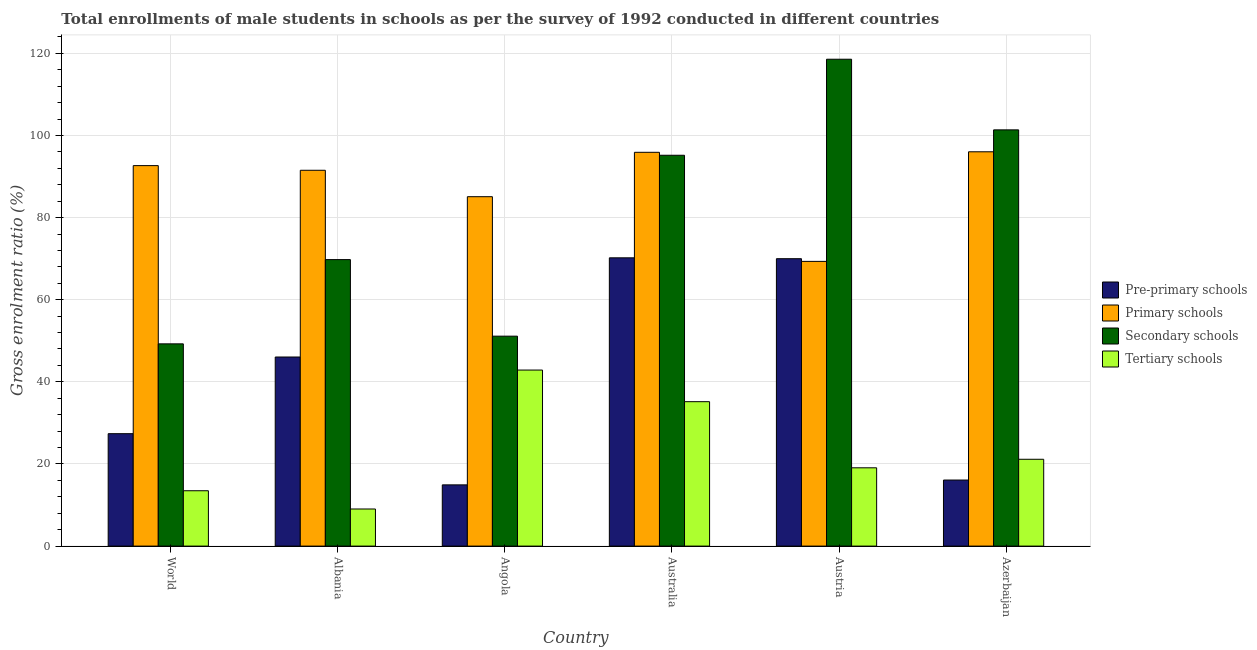How many different coloured bars are there?
Give a very brief answer. 4. How many groups of bars are there?
Ensure brevity in your answer.  6. Are the number of bars per tick equal to the number of legend labels?
Provide a succinct answer. Yes. Are the number of bars on each tick of the X-axis equal?
Your response must be concise. Yes. How many bars are there on the 1st tick from the left?
Make the answer very short. 4. What is the label of the 6th group of bars from the left?
Your answer should be very brief. Azerbaijan. What is the gross enrolment ratio(male) in secondary schools in Angola?
Make the answer very short. 51.12. Across all countries, what is the maximum gross enrolment ratio(male) in secondary schools?
Your answer should be compact. 118.57. Across all countries, what is the minimum gross enrolment ratio(male) in secondary schools?
Make the answer very short. 49.25. In which country was the gross enrolment ratio(male) in pre-primary schools minimum?
Ensure brevity in your answer.  Angola. What is the total gross enrolment ratio(male) in pre-primary schools in the graph?
Offer a very short reply. 244.62. What is the difference between the gross enrolment ratio(male) in secondary schools in Albania and that in Australia?
Your response must be concise. -25.41. What is the difference between the gross enrolment ratio(male) in pre-primary schools in Australia and the gross enrolment ratio(male) in primary schools in Azerbaijan?
Make the answer very short. -25.82. What is the average gross enrolment ratio(male) in primary schools per country?
Your response must be concise. 88.42. What is the difference between the gross enrolment ratio(male) in pre-primary schools and gross enrolment ratio(male) in tertiary schools in Austria?
Provide a succinct answer. 50.92. In how many countries, is the gross enrolment ratio(male) in secondary schools greater than 88 %?
Your answer should be compact. 3. What is the ratio of the gross enrolment ratio(male) in pre-primary schools in Angola to that in Azerbaijan?
Offer a terse response. 0.93. Is the gross enrolment ratio(male) in tertiary schools in Angola less than that in World?
Your answer should be compact. No. Is the difference between the gross enrolment ratio(male) in pre-primary schools in Australia and Azerbaijan greater than the difference between the gross enrolment ratio(male) in secondary schools in Australia and Azerbaijan?
Give a very brief answer. Yes. What is the difference between the highest and the second highest gross enrolment ratio(male) in tertiary schools?
Give a very brief answer. 7.7. What is the difference between the highest and the lowest gross enrolment ratio(male) in tertiary schools?
Offer a terse response. 33.84. In how many countries, is the gross enrolment ratio(male) in pre-primary schools greater than the average gross enrolment ratio(male) in pre-primary schools taken over all countries?
Give a very brief answer. 3. Is it the case that in every country, the sum of the gross enrolment ratio(male) in tertiary schools and gross enrolment ratio(male) in secondary schools is greater than the sum of gross enrolment ratio(male) in pre-primary schools and gross enrolment ratio(male) in primary schools?
Your response must be concise. No. What does the 3rd bar from the left in Azerbaijan represents?
Your response must be concise. Secondary schools. What does the 1st bar from the right in Azerbaijan represents?
Keep it short and to the point. Tertiary schools. What is the difference between two consecutive major ticks on the Y-axis?
Ensure brevity in your answer.  20. Are the values on the major ticks of Y-axis written in scientific E-notation?
Your answer should be very brief. No. Does the graph contain grids?
Ensure brevity in your answer.  Yes. Where does the legend appear in the graph?
Give a very brief answer. Center right. How are the legend labels stacked?
Ensure brevity in your answer.  Vertical. What is the title of the graph?
Your response must be concise. Total enrollments of male students in schools as per the survey of 1992 conducted in different countries. What is the label or title of the Y-axis?
Offer a very short reply. Gross enrolment ratio (%). What is the Gross enrolment ratio (%) in Pre-primary schools in World?
Offer a very short reply. 27.38. What is the Gross enrolment ratio (%) in Primary schools in World?
Make the answer very short. 92.66. What is the Gross enrolment ratio (%) of Secondary schools in World?
Offer a terse response. 49.25. What is the Gross enrolment ratio (%) in Tertiary schools in World?
Provide a short and direct response. 13.48. What is the Gross enrolment ratio (%) in Pre-primary schools in Albania?
Offer a terse response. 46.05. What is the Gross enrolment ratio (%) of Primary schools in Albania?
Ensure brevity in your answer.  91.53. What is the Gross enrolment ratio (%) of Secondary schools in Albania?
Give a very brief answer. 69.77. What is the Gross enrolment ratio (%) of Tertiary schools in Albania?
Provide a succinct answer. 9.04. What is the Gross enrolment ratio (%) of Pre-primary schools in Angola?
Offer a terse response. 14.91. What is the Gross enrolment ratio (%) in Primary schools in Angola?
Ensure brevity in your answer.  85.09. What is the Gross enrolment ratio (%) of Secondary schools in Angola?
Keep it short and to the point. 51.12. What is the Gross enrolment ratio (%) in Tertiary schools in Angola?
Offer a terse response. 42.87. What is the Gross enrolment ratio (%) of Pre-primary schools in Australia?
Provide a succinct answer. 70.2. What is the Gross enrolment ratio (%) in Primary schools in Australia?
Give a very brief answer. 95.9. What is the Gross enrolment ratio (%) of Secondary schools in Australia?
Offer a very short reply. 95.18. What is the Gross enrolment ratio (%) in Tertiary schools in Australia?
Your response must be concise. 35.17. What is the Gross enrolment ratio (%) of Pre-primary schools in Austria?
Provide a succinct answer. 69.99. What is the Gross enrolment ratio (%) in Primary schools in Austria?
Provide a succinct answer. 69.34. What is the Gross enrolment ratio (%) in Secondary schools in Austria?
Provide a short and direct response. 118.57. What is the Gross enrolment ratio (%) of Tertiary schools in Austria?
Your answer should be very brief. 19.07. What is the Gross enrolment ratio (%) in Pre-primary schools in Azerbaijan?
Provide a succinct answer. 16.09. What is the Gross enrolment ratio (%) of Primary schools in Azerbaijan?
Provide a short and direct response. 96.03. What is the Gross enrolment ratio (%) in Secondary schools in Azerbaijan?
Your answer should be compact. 101.37. What is the Gross enrolment ratio (%) of Tertiary schools in Azerbaijan?
Keep it short and to the point. 21.14. Across all countries, what is the maximum Gross enrolment ratio (%) of Pre-primary schools?
Offer a very short reply. 70.2. Across all countries, what is the maximum Gross enrolment ratio (%) of Primary schools?
Give a very brief answer. 96.03. Across all countries, what is the maximum Gross enrolment ratio (%) in Secondary schools?
Keep it short and to the point. 118.57. Across all countries, what is the maximum Gross enrolment ratio (%) in Tertiary schools?
Your answer should be compact. 42.87. Across all countries, what is the minimum Gross enrolment ratio (%) in Pre-primary schools?
Make the answer very short. 14.91. Across all countries, what is the minimum Gross enrolment ratio (%) in Primary schools?
Offer a very short reply. 69.34. Across all countries, what is the minimum Gross enrolment ratio (%) of Secondary schools?
Your answer should be compact. 49.25. Across all countries, what is the minimum Gross enrolment ratio (%) of Tertiary schools?
Your answer should be very brief. 9.04. What is the total Gross enrolment ratio (%) of Pre-primary schools in the graph?
Your answer should be compact. 244.62. What is the total Gross enrolment ratio (%) in Primary schools in the graph?
Make the answer very short. 530.55. What is the total Gross enrolment ratio (%) of Secondary schools in the graph?
Offer a terse response. 485.27. What is the total Gross enrolment ratio (%) of Tertiary schools in the graph?
Keep it short and to the point. 140.77. What is the difference between the Gross enrolment ratio (%) in Pre-primary schools in World and that in Albania?
Your answer should be compact. -18.67. What is the difference between the Gross enrolment ratio (%) of Primary schools in World and that in Albania?
Provide a succinct answer. 1.13. What is the difference between the Gross enrolment ratio (%) of Secondary schools in World and that in Albania?
Provide a short and direct response. -20.52. What is the difference between the Gross enrolment ratio (%) of Tertiary schools in World and that in Albania?
Provide a succinct answer. 4.45. What is the difference between the Gross enrolment ratio (%) of Pre-primary schools in World and that in Angola?
Provide a succinct answer. 12.47. What is the difference between the Gross enrolment ratio (%) in Primary schools in World and that in Angola?
Provide a succinct answer. 7.57. What is the difference between the Gross enrolment ratio (%) of Secondary schools in World and that in Angola?
Your response must be concise. -1.87. What is the difference between the Gross enrolment ratio (%) of Tertiary schools in World and that in Angola?
Your answer should be very brief. -29.39. What is the difference between the Gross enrolment ratio (%) in Pre-primary schools in World and that in Australia?
Your response must be concise. -42.82. What is the difference between the Gross enrolment ratio (%) of Primary schools in World and that in Australia?
Offer a terse response. -3.24. What is the difference between the Gross enrolment ratio (%) of Secondary schools in World and that in Australia?
Offer a terse response. -45.93. What is the difference between the Gross enrolment ratio (%) of Tertiary schools in World and that in Australia?
Provide a succinct answer. -21.69. What is the difference between the Gross enrolment ratio (%) of Pre-primary schools in World and that in Austria?
Your response must be concise. -42.61. What is the difference between the Gross enrolment ratio (%) in Primary schools in World and that in Austria?
Provide a succinct answer. 23.32. What is the difference between the Gross enrolment ratio (%) in Secondary schools in World and that in Austria?
Your answer should be compact. -69.32. What is the difference between the Gross enrolment ratio (%) in Tertiary schools in World and that in Austria?
Provide a succinct answer. -5.58. What is the difference between the Gross enrolment ratio (%) of Pre-primary schools in World and that in Azerbaijan?
Ensure brevity in your answer.  11.29. What is the difference between the Gross enrolment ratio (%) in Primary schools in World and that in Azerbaijan?
Your response must be concise. -3.37. What is the difference between the Gross enrolment ratio (%) of Secondary schools in World and that in Azerbaijan?
Provide a short and direct response. -52.11. What is the difference between the Gross enrolment ratio (%) of Tertiary schools in World and that in Azerbaijan?
Your answer should be very brief. -7.66. What is the difference between the Gross enrolment ratio (%) in Pre-primary schools in Albania and that in Angola?
Provide a succinct answer. 31.14. What is the difference between the Gross enrolment ratio (%) of Primary schools in Albania and that in Angola?
Your answer should be compact. 6.44. What is the difference between the Gross enrolment ratio (%) in Secondary schools in Albania and that in Angola?
Ensure brevity in your answer.  18.65. What is the difference between the Gross enrolment ratio (%) in Tertiary schools in Albania and that in Angola?
Keep it short and to the point. -33.84. What is the difference between the Gross enrolment ratio (%) in Pre-primary schools in Albania and that in Australia?
Give a very brief answer. -24.15. What is the difference between the Gross enrolment ratio (%) of Primary schools in Albania and that in Australia?
Keep it short and to the point. -4.38. What is the difference between the Gross enrolment ratio (%) of Secondary schools in Albania and that in Australia?
Offer a very short reply. -25.41. What is the difference between the Gross enrolment ratio (%) in Tertiary schools in Albania and that in Australia?
Your answer should be compact. -26.14. What is the difference between the Gross enrolment ratio (%) in Pre-primary schools in Albania and that in Austria?
Provide a succinct answer. -23.94. What is the difference between the Gross enrolment ratio (%) of Primary schools in Albania and that in Austria?
Provide a succinct answer. 22.19. What is the difference between the Gross enrolment ratio (%) of Secondary schools in Albania and that in Austria?
Offer a very short reply. -48.8. What is the difference between the Gross enrolment ratio (%) of Tertiary schools in Albania and that in Austria?
Your answer should be very brief. -10.03. What is the difference between the Gross enrolment ratio (%) in Pre-primary schools in Albania and that in Azerbaijan?
Ensure brevity in your answer.  29.96. What is the difference between the Gross enrolment ratio (%) of Primary schools in Albania and that in Azerbaijan?
Provide a short and direct response. -4.5. What is the difference between the Gross enrolment ratio (%) of Secondary schools in Albania and that in Azerbaijan?
Keep it short and to the point. -31.6. What is the difference between the Gross enrolment ratio (%) in Tertiary schools in Albania and that in Azerbaijan?
Provide a short and direct response. -12.11. What is the difference between the Gross enrolment ratio (%) in Pre-primary schools in Angola and that in Australia?
Provide a succinct answer. -55.29. What is the difference between the Gross enrolment ratio (%) of Primary schools in Angola and that in Australia?
Provide a succinct answer. -10.81. What is the difference between the Gross enrolment ratio (%) of Secondary schools in Angola and that in Australia?
Make the answer very short. -44.06. What is the difference between the Gross enrolment ratio (%) in Tertiary schools in Angola and that in Australia?
Ensure brevity in your answer.  7.7. What is the difference between the Gross enrolment ratio (%) in Pre-primary schools in Angola and that in Austria?
Make the answer very short. -55.08. What is the difference between the Gross enrolment ratio (%) in Primary schools in Angola and that in Austria?
Make the answer very short. 15.75. What is the difference between the Gross enrolment ratio (%) of Secondary schools in Angola and that in Austria?
Your response must be concise. -67.45. What is the difference between the Gross enrolment ratio (%) in Tertiary schools in Angola and that in Austria?
Ensure brevity in your answer.  23.81. What is the difference between the Gross enrolment ratio (%) in Pre-primary schools in Angola and that in Azerbaijan?
Offer a very short reply. -1.18. What is the difference between the Gross enrolment ratio (%) of Primary schools in Angola and that in Azerbaijan?
Provide a short and direct response. -10.94. What is the difference between the Gross enrolment ratio (%) of Secondary schools in Angola and that in Azerbaijan?
Provide a succinct answer. -50.24. What is the difference between the Gross enrolment ratio (%) of Tertiary schools in Angola and that in Azerbaijan?
Your answer should be very brief. 21.73. What is the difference between the Gross enrolment ratio (%) in Pre-primary schools in Australia and that in Austria?
Offer a very short reply. 0.21. What is the difference between the Gross enrolment ratio (%) in Primary schools in Australia and that in Austria?
Your answer should be compact. 26.56. What is the difference between the Gross enrolment ratio (%) of Secondary schools in Australia and that in Austria?
Your answer should be very brief. -23.39. What is the difference between the Gross enrolment ratio (%) in Tertiary schools in Australia and that in Austria?
Make the answer very short. 16.11. What is the difference between the Gross enrolment ratio (%) of Pre-primary schools in Australia and that in Azerbaijan?
Ensure brevity in your answer.  54.12. What is the difference between the Gross enrolment ratio (%) in Primary schools in Australia and that in Azerbaijan?
Provide a succinct answer. -0.12. What is the difference between the Gross enrolment ratio (%) of Secondary schools in Australia and that in Azerbaijan?
Provide a succinct answer. -6.18. What is the difference between the Gross enrolment ratio (%) in Tertiary schools in Australia and that in Azerbaijan?
Make the answer very short. 14.03. What is the difference between the Gross enrolment ratio (%) in Pre-primary schools in Austria and that in Azerbaijan?
Provide a succinct answer. 53.9. What is the difference between the Gross enrolment ratio (%) in Primary schools in Austria and that in Azerbaijan?
Provide a short and direct response. -26.69. What is the difference between the Gross enrolment ratio (%) in Secondary schools in Austria and that in Azerbaijan?
Your answer should be very brief. 17.2. What is the difference between the Gross enrolment ratio (%) in Tertiary schools in Austria and that in Azerbaijan?
Your response must be concise. -2.08. What is the difference between the Gross enrolment ratio (%) of Pre-primary schools in World and the Gross enrolment ratio (%) of Primary schools in Albania?
Offer a terse response. -64.15. What is the difference between the Gross enrolment ratio (%) of Pre-primary schools in World and the Gross enrolment ratio (%) of Secondary schools in Albania?
Provide a short and direct response. -42.39. What is the difference between the Gross enrolment ratio (%) in Pre-primary schools in World and the Gross enrolment ratio (%) in Tertiary schools in Albania?
Provide a short and direct response. 18.34. What is the difference between the Gross enrolment ratio (%) of Primary schools in World and the Gross enrolment ratio (%) of Secondary schools in Albania?
Your answer should be compact. 22.89. What is the difference between the Gross enrolment ratio (%) in Primary schools in World and the Gross enrolment ratio (%) in Tertiary schools in Albania?
Offer a very short reply. 83.62. What is the difference between the Gross enrolment ratio (%) of Secondary schools in World and the Gross enrolment ratio (%) of Tertiary schools in Albania?
Keep it short and to the point. 40.22. What is the difference between the Gross enrolment ratio (%) of Pre-primary schools in World and the Gross enrolment ratio (%) of Primary schools in Angola?
Provide a short and direct response. -57.71. What is the difference between the Gross enrolment ratio (%) of Pre-primary schools in World and the Gross enrolment ratio (%) of Secondary schools in Angola?
Your answer should be very brief. -23.75. What is the difference between the Gross enrolment ratio (%) in Pre-primary schools in World and the Gross enrolment ratio (%) in Tertiary schools in Angola?
Your response must be concise. -15.49. What is the difference between the Gross enrolment ratio (%) in Primary schools in World and the Gross enrolment ratio (%) in Secondary schools in Angola?
Give a very brief answer. 41.53. What is the difference between the Gross enrolment ratio (%) of Primary schools in World and the Gross enrolment ratio (%) of Tertiary schools in Angola?
Give a very brief answer. 49.79. What is the difference between the Gross enrolment ratio (%) in Secondary schools in World and the Gross enrolment ratio (%) in Tertiary schools in Angola?
Your response must be concise. 6.38. What is the difference between the Gross enrolment ratio (%) of Pre-primary schools in World and the Gross enrolment ratio (%) of Primary schools in Australia?
Your answer should be very brief. -68.52. What is the difference between the Gross enrolment ratio (%) of Pre-primary schools in World and the Gross enrolment ratio (%) of Secondary schools in Australia?
Make the answer very short. -67.81. What is the difference between the Gross enrolment ratio (%) in Pre-primary schools in World and the Gross enrolment ratio (%) in Tertiary schools in Australia?
Ensure brevity in your answer.  -7.79. What is the difference between the Gross enrolment ratio (%) in Primary schools in World and the Gross enrolment ratio (%) in Secondary schools in Australia?
Provide a succinct answer. -2.52. What is the difference between the Gross enrolment ratio (%) in Primary schools in World and the Gross enrolment ratio (%) in Tertiary schools in Australia?
Keep it short and to the point. 57.49. What is the difference between the Gross enrolment ratio (%) of Secondary schools in World and the Gross enrolment ratio (%) of Tertiary schools in Australia?
Ensure brevity in your answer.  14.08. What is the difference between the Gross enrolment ratio (%) of Pre-primary schools in World and the Gross enrolment ratio (%) of Primary schools in Austria?
Ensure brevity in your answer.  -41.96. What is the difference between the Gross enrolment ratio (%) of Pre-primary schools in World and the Gross enrolment ratio (%) of Secondary schools in Austria?
Provide a short and direct response. -91.19. What is the difference between the Gross enrolment ratio (%) of Pre-primary schools in World and the Gross enrolment ratio (%) of Tertiary schools in Austria?
Provide a short and direct response. 8.31. What is the difference between the Gross enrolment ratio (%) of Primary schools in World and the Gross enrolment ratio (%) of Secondary schools in Austria?
Keep it short and to the point. -25.91. What is the difference between the Gross enrolment ratio (%) of Primary schools in World and the Gross enrolment ratio (%) of Tertiary schools in Austria?
Keep it short and to the point. 73.59. What is the difference between the Gross enrolment ratio (%) in Secondary schools in World and the Gross enrolment ratio (%) in Tertiary schools in Austria?
Provide a short and direct response. 30.19. What is the difference between the Gross enrolment ratio (%) of Pre-primary schools in World and the Gross enrolment ratio (%) of Primary schools in Azerbaijan?
Make the answer very short. -68.65. What is the difference between the Gross enrolment ratio (%) of Pre-primary schools in World and the Gross enrolment ratio (%) of Secondary schools in Azerbaijan?
Provide a succinct answer. -73.99. What is the difference between the Gross enrolment ratio (%) in Pre-primary schools in World and the Gross enrolment ratio (%) in Tertiary schools in Azerbaijan?
Your answer should be very brief. 6.23. What is the difference between the Gross enrolment ratio (%) of Primary schools in World and the Gross enrolment ratio (%) of Secondary schools in Azerbaijan?
Your answer should be compact. -8.71. What is the difference between the Gross enrolment ratio (%) in Primary schools in World and the Gross enrolment ratio (%) in Tertiary schools in Azerbaijan?
Your answer should be very brief. 71.51. What is the difference between the Gross enrolment ratio (%) in Secondary schools in World and the Gross enrolment ratio (%) in Tertiary schools in Azerbaijan?
Ensure brevity in your answer.  28.11. What is the difference between the Gross enrolment ratio (%) of Pre-primary schools in Albania and the Gross enrolment ratio (%) of Primary schools in Angola?
Give a very brief answer. -39.04. What is the difference between the Gross enrolment ratio (%) in Pre-primary schools in Albania and the Gross enrolment ratio (%) in Secondary schools in Angola?
Offer a very short reply. -5.07. What is the difference between the Gross enrolment ratio (%) in Pre-primary schools in Albania and the Gross enrolment ratio (%) in Tertiary schools in Angola?
Keep it short and to the point. 3.18. What is the difference between the Gross enrolment ratio (%) of Primary schools in Albania and the Gross enrolment ratio (%) of Secondary schools in Angola?
Make the answer very short. 40.4. What is the difference between the Gross enrolment ratio (%) in Primary schools in Albania and the Gross enrolment ratio (%) in Tertiary schools in Angola?
Ensure brevity in your answer.  48.66. What is the difference between the Gross enrolment ratio (%) in Secondary schools in Albania and the Gross enrolment ratio (%) in Tertiary schools in Angola?
Keep it short and to the point. 26.9. What is the difference between the Gross enrolment ratio (%) in Pre-primary schools in Albania and the Gross enrolment ratio (%) in Primary schools in Australia?
Your answer should be very brief. -49.85. What is the difference between the Gross enrolment ratio (%) in Pre-primary schools in Albania and the Gross enrolment ratio (%) in Secondary schools in Australia?
Keep it short and to the point. -49.13. What is the difference between the Gross enrolment ratio (%) of Pre-primary schools in Albania and the Gross enrolment ratio (%) of Tertiary schools in Australia?
Provide a succinct answer. 10.88. What is the difference between the Gross enrolment ratio (%) of Primary schools in Albania and the Gross enrolment ratio (%) of Secondary schools in Australia?
Offer a very short reply. -3.66. What is the difference between the Gross enrolment ratio (%) in Primary schools in Albania and the Gross enrolment ratio (%) in Tertiary schools in Australia?
Keep it short and to the point. 56.36. What is the difference between the Gross enrolment ratio (%) in Secondary schools in Albania and the Gross enrolment ratio (%) in Tertiary schools in Australia?
Offer a very short reply. 34.6. What is the difference between the Gross enrolment ratio (%) of Pre-primary schools in Albania and the Gross enrolment ratio (%) of Primary schools in Austria?
Your answer should be compact. -23.29. What is the difference between the Gross enrolment ratio (%) of Pre-primary schools in Albania and the Gross enrolment ratio (%) of Secondary schools in Austria?
Offer a very short reply. -72.52. What is the difference between the Gross enrolment ratio (%) in Pre-primary schools in Albania and the Gross enrolment ratio (%) in Tertiary schools in Austria?
Provide a short and direct response. 26.98. What is the difference between the Gross enrolment ratio (%) in Primary schools in Albania and the Gross enrolment ratio (%) in Secondary schools in Austria?
Provide a succinct answer. -27.04. What is the difference between the Gross enrolment ratio (%) in Primary schools in Albania and the Gross enrolment ratio (%) in Tertiary schools in Austria?
Your answer should be compact. 72.46. What is the difference between the Gross enrolment ratio (%) of Secondary schools in Albania and the Gross enrolment ratio (%) of Tertiary schools in Austria?
Your answer should be very brief. 50.7. What is the difference between the Gross enrolment ratio (%) in Pre-primary schools in Albania and the Gross enrolment ratio (%) in Primary schools in Azerbaijan?
Offer a very short reply. -49.98. What is the difference between the Gross enrolment ratio (%) in Pre-primary schools in Albania and the Gross enrolment ratio (%) in Secondary schools in Azerbaijan?
Give a very brief answer. -55.32. What is the difference between the Gross enrolment ratio (%) of Pre-primary schools in Albania and the Gross enrolment ratio (%) of Tertiary schools in Azerbaijan?
Provide a short and direct response. 24.91. What is the difference between the Gross enrolment ratio (%) of Primary schools in Albania and the Gross enrolment ratio (%) of Secondary schools in Azerbaijan?
Your answer should be compact. -9.84. What is the difference between the Gross enrolment ratio (%) in Primary schools in Albania and the Gross enrolment ratio (%) in Tertiary schools in Azerbaijan?
Offer a very short reply. 70.38. What is the difference between the Gross enrolment ratio (%) in Secondary schools in Albania and the Gross enrolment ratio (%) in Tertiary schools in Azerbaijan?
Make the answer very short. 48.63. What is the difference between the Gross enrolment ratio (%) of Pre-primary schools in Angola and the Gross enrolment ratio (%) of Primary schools in Australia?
Ensure brevity in your answer.  -80.99. What is the difference between the Gross enrolment ratio (%) of Pre-primary schools in Angola and the Gross enrolment ratio (%) of Secondary schools in Australia?
Provide a succinct answer. -80.27. What is the difference between the Gross enrolment ratio (%) of Pre-primary schools in Angola and the Gross enrolment ratio (%) of Tertiary schools in Australia?
Your answer should be compact. -20.26. What is the difference between the Gross enrolment ratio (%) of Primary schools in Angola and the Gross enrolment ratio (%) of Secondary schools in Australia?
Offer a terse response. -10.09. What is the difference between the Gross enrolment ratio (%) in Primary schools in Angola and the Gross enrolment ratio (%) in Tertiary schools in Australia?
Your answer should be compact. 49.92. What is the difference between the Gross enrolment ratio (%) of Secondary schools in Angola and the Gross enrolment ratio (%) of Tertiary schools in Australia?
Give a very brief answer. 15.95. What is the difference between the Gross enrolment ratio (%) in Pre-primary schools in Angola and the Gross enrolment ratio (%) in Primary schools in Austria?
Keep it short and to the point. -54.43. What is the difference between the Gross enrolment ratio (%) of Pre-primary schools in Angola and the Gross enrolment ratio (%) of Secondary schools in Austria?
Your answer should be compact. -103.66. What is the difference between the Gross enrolment ratio (%) of Pre-primary schools in Angola and the Gross enrolment ratio (%) of Tertiary schools in Austria?
Your answer should be compact. -4.15. What is the difference between the Gross enrolment ratio (%) of Primary schools in Angola and the Gross enrolment ratio (%) of Secondary schools in Austria?
Give a very brief answer. -33.48. What is the difference between the Gross enrolment ratio (%) of Primary schools in Angola and the Gross enrolment ratio (%) of Tertiary schools in Austria?
Offer a very short reply. 66.03. What is the difference between the Gross enrolment ratio (%) of Secondary schools in Angola and the Gross enrolment ratio (%) of Tertiary schools in Austria?
Make the answer very short. 32.06. What is the difference between the Gross enrolment ratio (%) of Pre-primary schools in Angola and the Gross enrolment ratio (%) of Primary schools in Azerbaijan?
Ensure brevity in your answer.  -81.11. What is the difference between the Gross enrolment ratio (%) of Pre-primary schools in Angola and the Gross enrolment ratio (%) of Secondary schools in Azerbaijan?
Provide a succinct answer. -86.45. What is the difference between the Gross enrolment ratio (%) of Pre-primary schools in Angola and the Gross enrolment ratio (%) of Tertiary schools in Azerbaijan?
Provide a short and direct response. -6.23. What is the difference between the Gross enrolment ratio (%) of Primary schools in Angola and the Gross enrolment ratio (%) of Secondary schools in Azerbaijan?
Your answer should be compact. -16.27. What is the difference between the Gross enrolment ratio (%) of Primary schools in Angola and the Gross enrolment ratio (%) of Tertiary schools in Azerbaijan?
Give a very brief answer. 63.95. What is the difference between the Gross enrolment ratio (%) in Secondary schools in Angola and the Gross enrolment ratio (%) in Tertiary schools in Azerbaijan?
Offer a terse response. 29.98. What is the difference between the Gross enrolment ratio (%) in Pre-primary schools in Australia and the Gross enrolment ratio (%) in Primary schools in Austria?
Your answer should be compact. 0.86. What is the difference between the Gross enrolment ratio (%) of Pre-primary schools in Australia and the Gross enrolment ratio (%) of Secondary schools in Austria?
Make the answer very short. -48.37. What is the difference between the Gross enrolment ratio (%) of Pre-primary schools in Australia and the Gross enrolment ratio (%) of Tertiary schools in Austria?
Provide a succinct answer. 51.14. What is the difference between the Gross enrolment ratio (%) in Primary schools in Australia and the Gross enrolment ratio (%) in Secondary schools in Austria?
Provide a short and direct response. -22.67. What is the difference between the Gross enrolment ratio (%) of Primary schools in Australia and the Gross enrolment ratio (%) of Tertiary schools in Austria?
Make the answer very short. 76.84. What is the difference between the Gross enrolment ratio (%) in Secondary schools in Australia and the Gross enrolment ratio (%) in Tertiary schools in Austria?
Your answer should be compact. 76.12. What is the difference between the Gross enrolment ratio (%) in Pre-primary schools in Australia and the Gross enrolment ratio (%) in Primary schools in Azerbaijan?
Give a very brief answer. -25.82. What is the difference between the Gross enrolment ratio (%) in Pre-primary schools in Australia and the Gross enrolment ratio (%) in Secondary schools in Azerbaijan?
Make the answer very short. -31.16. What is the difference between the Gross enrolment ratio (%) in Pre-primary schools in Australia and the Gross enrolment ratio (%) in Tertiary schools in Azerbaijan?
Offer a very short reply. 49.06. What is the difference between the Gross enrolment ratio (%) of Primary schools in Australia and the Gross enrolment ratio (%) of Secondary schools in Azerbaijan?
Give a very brief answer. -5.46. What is the difference between the Gross enrolment ratio (%) in Primary schools in Australia and the Gross enrolment ratio (%) in Tertiary schools in Azerbaijan?
Ensure brevity in your answer.  74.76. What is the difference between the Gross enrolment ratio (%) of Secondary schools in Australia and the Gross enrolment ratio (%) of Tertiary schools in Azerbaijan?
Make the answer very short. 74.04. What is the difference between the Gross enrolment ratio (%) of Pre-primary schools in Austria and the Gross enrolment ratio (%) of Primary schools in Azerbaijan?
Provide a succinct answer. -26.04. What is the difference between the Gross enrolment ratio (%) of Pre-primary schools in Austria and the Gross enrolment ratio (%) of Secondary schools in Azerbaijan?
Give a very brief answer. -31.38. What is the difference between the Gross enrolment ratio (%) of Pre-primary schools in Austria and the Gross enrolment ratio (%) of Tertiary schools in Azerbaijan?
Keep it short and to the point. 48.85. What is the difference between the Gross enrolment ratio (%) of Primary schools in Austria and the Gross enrolment ratio (%) of Secondary schools in Azerbaijan?
Give a very brief answer. -32.03. What is the difference between the Gross enrolment ratio (%) of Primary schools in Austria and the Gross enrolment ratio (%) of Tertiary schools in Azerbaijan?
Provide a succinct answer. 48.19. What is the difference between the Gross enrolment ratio (%) of Secondary schools in Austria and the Gross enrolment ratio (%) of Tertiary schools in Azerbaijan?
Offer a very short reply. 97.43. What is the average Gross enrolment ratio (%) of Pre-primary schools per country?
Your answer should be compact. 40.77. What is the average Gross enrolment ratio (%) in Primary schools per country?
Provide a short and direct response. 88.42. What is the average Gross enrolment ratio (%) in Secondary schools per country?
Your response must be concise. 80.88. What is the average Gross enrolment ratio (%) in Tertiary schools per country?
Provide a succinct answer. 23.46. What is the difference between the Gross enrolment ratio (%) in Pre-primary schools and Gross enrolment ratio (%) in Primary schools in World?
Your response must be concise. -65.28. What is the difference between the Gross enrolment ratio (%) of Pre-primary schools and Gross enrolment ratio (%) of Secondary schools in World?
Your response must be concise. -21.88. What is the difference between the Gross enrolment ratio (%) in Pre-primary schools and Gross enrolment ratio (%) in Tertiary schools in World?
Your answer should be very brief. 13.9. What is the difference between the Gross enrolment ratio (%) in Primary schools and Gross enrolment ratio (%) in Secondary schools in World?
Provide a short and direct response. 43.41. What is the difference between the Gross enrolment ratio (%) of Primary schools and Gross enrolment ratio (%) of Tertiary schools in World?
Your answer should be compact. 79.18. What is the difference between the Gross enrolment ratio (%) in Secondary schools and Gross enrolment ratio (%) in Tertiary schools in World?
Keep it short and to the point. 35.77. What is the difference between the Gross enrolment ratio (%) of Pre-primary schools and Gross enrolment ratio (%) of Primary schools in Albania?
Give a very brief answer. -45.48. What is the difference between the Gross enrolment ratio (%) of Pre-primary schools and Gross enrolment ratio (%) of Secondary schools in Albania?
Your answer should be compact. -23.72. What is the difference between the Gross enrolment ratio (%) in Pre-primary schools and Gross enrolment ratio (%) in Tertiary schools in Albania?
Make the answer very short. 37.01. What is the difference between the Gross enrolment ratio (%) in Primary schools and Gross enrolment ratio (%) in Secondary schools in Albania?
Your response must be concise. 21.76. What is the difference between the Gross enrolment ratio (%) of Primary schools and Gross enrolment ratio (%) of Tertiary schools in Albania?
Your response must be concise. 82.49. What is the difference between the Gross enrolment ratio (%) of Secondary schools and Gross enrolment ratio (%) of Tertiary schools in Albania?
Make the answer very short. 60.73. What is the difference between the Gross enrolment ratio (%) in Pre-primary schools and Gross enrolment ratio (%) in Primary schools in Angola?
Provide a succinct answer. -70.18. What is the difference between the Gross enrolment ratio (%) of Pre-primary schools and Gross enrolment ratio (%) of Secondary schools in Angola?
Keep it short and to the point. -36.21. What is the difference between the Gross enrolment ratio (%) in Pre-primary schools and Gross enrolment ratio (%) in Tertiary schools in Angola?
Provide a succinct answer. -27.96. What is the difference between the Gross enrolment ratio (%) of Primary schools and Gross enrolment ratio (%) of Secondary schools in Angola?
Your response must be concise. 33.97. What is the difference between the Gross enrolment ratio (%) in Primary schools and Gross enrolment ratio (%) in Tertiary schools in Angola?
Your answer should be very brief. 42.22. What is the difference between the Gross enrolment ratio (%) in Secondary schools and Gross enrolment ratio (%) in Tertiary schools in Angola?
Offer a very short reply. 8.25. What is the difference between the Gross enrolment ratio (%) in Pre-primary schools and Gross enrolment ratio (%) in Primary schools in Australia?
Provide a succinct answer. -25.7. What is the difference between the Gross enrolment ratio (%) in Pre-primary schools and Gross enrolment ratio (%) in Secondary schools in Australia?
Give a very brief answer. -24.98. What is the difference between the Gross enrolment ratio (%) of Pre-primary schools and Gross enrolment ratio (%) of Tertiary schools in Australia?
Give a very brief answer. 35.03. What is the difference between the Gross enrolment ratio (%) of Primary schools and Gross enrolment ratio (%) of Secondary schools in Australia?
Provide a succinct answer. 0.72. What is the difference between the Gross enrolment ratio (%) of Primary schools and Gross enrolment ratio (%) of Tertiary schools in Australia?
Your answer should be very brief. 60.73. What is the difference between the Gross enrolment ratio (%) in Secondary schools and Gross enrolment ratio (%) in Tertiary schools in Australia?
Keep it short and to the point. 60.01. What is the difference between the Gross enrolment ratio (%) in Pre-primary schools and Gross enrolment ratio (%) in Primary schools in Austria?
Offer a terse response. 0.65. What is the difference between the Gross enrolment ratio (%) of Pre-primary schools and Gross enrolment ratio (%) of Secondary schools in Austria?
Ensure brevity in your answer.  -48.58. What is the difference between the Gross enrolment ratio (%) of Pre-primary schools and Gross enrolment ratio (%) of Tertiary schools in Austria?
Keep it short and to the point. 50.92. What is the difference between the Gross enrolment ratio (%) of Primary schools and Gross enrolment ratio (%) of Secondary schools in Austria?
Keep it short and to the point. -49.23. What is the difference between the Gross enrolment ratio (%) in Primary schools and Gross enrolment ratio (%) in Tertiary schools in Austria?
Your answer should be compact. 50.27. What is the difference between the Gross enrolment ratio (%) in Secondary schools and Gross enrolment ratio (%) in Tertiary schools in Austria?
Offer a terse response. 99.5. What is the difference between the Gross enrolment ratio (%) of Pre-primary schools and Gross enrolment ratio (%) of Primary schools in Azerbaijan?
Your answer should be very brief. -79.94. What is the difference between the Gross enrolment ratio (%) in Pre-primary schools and Gross enrolment ratio (%) in Secondary schools in Azerbaijan?
Give a very brief answer. -85.28. What is the difference between the Gross enrolment ratio (%) of Pre-primary schools and Gross enrolment ratio (%) of Tertiary schools in Azerbaijan?
Your response must be concise. -5.06. What is the difference between the Gross enrolment ratio (%) in Primary schools and Gross enrolment ratio (%) in Secondary schools in Azerbaijan?
Keep it short and to the point. -5.34. What is the difference between the Gross enrolment ratio (%) in Primary schools and Gross enrolment ratio (%) in Tertiary schools in Azerbaijan?
Your answer should be compact. 74.88. What is the difference between the Gross enrolment ratio (%) of Secondary schools and Gross enrolment ratio (%) of Tertiary schools in Azerbaijan?
Make the answer very short. 80.22. What is the ratio of the Gross enrolment ratio (%) in Pre-primary schools in World to that in Albania?
Keep it short and to the point. 0.59. What is the ratio of the Gross enrolment ratio (%) in Primary schools in World to that in Albania?
Your response must be concise. 1.01. What is the ratio of the Gross enrolment ratio (%) of Secondary schools in World to that in Albania?
Keep it short and to the point. 0.71. What is the ratio of the Gross enrolment ratio (%) in Tertiary schools in World to that in Albania?
Provide a succinct answer. 1.49. What is the ratio of the Gross enrolment ratio (%) of Pre-primary schools in World to that in Angola?
Make the answer very short. 1.84. What is the ratio of the Gross enrolment ratio (%) in Primary schools in World to that in Angola?
Make the answer very short. 1.09. What is the ratio of the Gross enrolment ratio (%) of Secondary schools in World to that in Angola?
Keep it short and to the point. 0.96. What is the ratio of the Gross enrolment ratio (%) in Tertiary schools in World to that in Angola?
Give a very brief answer. 0.31. What is the ratio of the Gross enrolment ratio (%) of Pre-primary schools in World to that in Australia?
Offer a terse response. 0.39. What is the ratio of the Gross enrolment ratio (%) in Primary schools in World to that in Australia?
Your answer should be compact. 0.97. What is the ratio of the Gross enrolment ratio (%) in Secondary schools in World to that in Australia?
Give a very brief answer. 0.52. What is the ratio of the Gross enrolment ratio (%) in Tertiary schools in World to that in Australia?
Give a very brief answer. 0.38. What is the ratio of the Gross enrolment ratio (%) of Pre-primary schools in World to that in Austria?
Make the answer very short. 0.39. What is the ratio of the Gross enrolment ratio (%) of Primary schools in World to that in Austria?
Keep it short and to the point. 1.34. What is the ratio of the Gross enrolment ratio (%) of Secondary schools in World to that in Austria?
Provide a short and direct response. 0.42. What is the ratio of the Gross enrolment ratio (%) in Tertiary schools in World to that in Austria?
Your answer should be very brief. 0.71. What is the ratio of the Gross enrolment ratio (%) of Pre-primary schools in World to that in Azerbaijan?
Provide a succinct answer. 1.7. What is the ratio of the Gross enrolment ratio (%) of Primary schools in World to that in Azerbaijan?
Offer a very short reply. 0.96. What is the ratio of the Gross enrolment ratio (%) in Secondary schools in World to that in Azerbaijan?
Provide a short and direct response. 0.49. What is the ratio of the Gross enrolment ratio (%) in Tertiary schools in World to that in Azerbaijan?
Ensure brevity in your answer.  0.64. What is the ratio of the Gross enrolment ratio (%) in Pre-primary schools in Albania to that in Angola?
Make the answer very short. 3.09. What is the ratio of the Gross enrolment ratio (%) in Primary schools in Albania to that in Angola?
Your answer should be very brief. 1.08. What is the ratio of the Gross enrolment ratio (%) in Secondary schools in Albania to that in Angola?
Give a very brief answer. 1.36. What is the ratio of the Gross enrolment ratio (%) in Tertiary schools in Albania to that in Angola?
Your answer should be compact. 0.21. What is the ratio of the Gross enrolment ratio (%) in Pre-primary schools in Albania to that in Australia?
Ensure brevity in your answer.  0.66. What is the ratio of the Gross enrolment ratio (%) in Primary schools in Albania to that in Australia?
Your answer should be compact. 0.95. What is the ratio of the Gross enrolment ratio (%) of Secondary schools in Albania to that in Australia?
Make the answer very short. 0.73. What is the ratio of the Gross enrolment ratio (%) in Tertiary schools in Albania to that in Australia?
Provide a succinct answer. 0.26. What is the ratio of the Gross enrolment ratio (%) of Pre-primary schools in Albania to that in Austria?
Give a very brief answer. 0.66. What is the ratio of the Gross enrolment ratio (%) in Primary schools in Albania to that in Austria?
Provide a succinct answer. 1.32. What is the ratio of the Gross enrolment ratio (%) of Secondary schools in Albania to that in Austria?
Give a very brief answer. 0.59. What is the ratio of the Gross enrolment ratio (%) of Tertiary schools in Albania to that in Austria?
Offer a very short reply. 0.47. What is the ratio of the Gross enrolment ratio (%) of Pre-primary schools in Albania to that in Azerbaijan?
Provide a short and direct response. 2.86. What is the ratio of the Gross enrolment ratio (%) of Primary schools in Albania to that in Azerbaijan?
Provide a short and direct response. 0.95. What is the ratio of the Gross enrolment ratio (%) of Secondary schools in Albania to that in Azerbaijan?
Keep it short and to the point. 0.69. What is the ratio of the Gross enrolment ratio (%) of Tertiary schools in Albania to that in Azerbaijan?
Give a very brief answer. 0.43. What is the ratio of the Gross enrolment ratio (%) in Pre-primary schools in Angola to that in Australia?
Make the answer very short. 0.21. What is the ratio of the Gross enrolment ratio (%) of Primary schools in Angola to that in Australia?
Keep it short and to the point. 0.89. What is the ratio of the Gross enrolment ratio (%) in Secondary schools in Angola to that in Australia?
Ensure brevity in your answer.  0.54. What is the ratio of the Gross enrolment ratio (%) in Tertiary schools in Angola to that in Australia?
Your answer should be compact. 1.22. What is the ratio of the Gross enrolment ratio (%) of Pre-primary schools in Angola to that in Austria?
Your answer should be compact. 0.21. What is the ratio of the Gross enrolment ratio (%) of Primary schools in Angola to that in Austria?
Keep it short and to the point. 1.23. What is the ratio of the Gross enrolment ratio (%) of Secondary schools in Angola to that in Austria?
Give a very brief answer. 0.43. What is the ratio of the Gross enrolment ratio (%) of Tertiary schools in Angola to that in Austria?
Keep it short and to the point. 2.25. What is the ratio of the Gross enrolment ratio (%) in Pre-primary schools in Angola to that in Azerbaijan?
Offer a very short reply. 0.93. What is the ratio of the Gross enrolment ratio (%) of Primary schools in Angola to that in Azerbaijan?
Provide a short and direct response. 0.89. What is the ratio of the Gross enrolment ratio (%) of Secondary schools in Angola to that in Azerbaijan?
Keep it short and to the point. 0.5. What is the ratio of the Gross enrolment ratio (%) of Tertiary schools in Angola to that in Azerbaijan?
Keep it short and to the point. 2.03. What is the ratio of the Gross enrolment ratio (%) in Pre-primary schools in Australia to that in Austria?
Offer a terse response. 1. What is the ratio of the Gross enrolment ratio (%) of Primary schools in Australia to that in Austria?
Offer a terse response. 1.38. What is the ratio of the Gross enrolment ratio (%) of Secondary schools in Australia to that in Austria?
Offer a terse response. 0.8. What is the ratio of the Gross enrolment ratio (%) of Tertiary schools in Australia to that in Austria?
Your answer should be very brief. 1.84. What is the ratio of the Gross enrolment ratio (%) of Pre-primary schools in Australia to that in Azerbaijan?
Give a very brief answer. 4.36. What is the ratio of the Gross enrolment ratio (%) in Secondary schools in Australia to that in Azerbaijan?
Offer a very short reply. 0.94. What is the ratio of the Gross enrolment ratio (%) of Tertiary schools in Australia to that in Azerbaijan?
Provide a short and direct response. 1.66. What is the ratio of the Gross enrolment ratio (%) in Pre-primary schools in Austria to that in Azerbaijan?
Provide a short and direct response. 4.35. What is the ratio of the Gross enrolment ratio (%) in Primary schools in Austria to that in Azerbaijan?
Your answer should be compact. 0.72. What is the ratio of the Gross enrolment ratio (%) of Secondary schools in Austria to that in Azerbaijan?
Make the answer very short. 1.17. What is the ratio of the Gross enrolment ratio (%) of Tertiary schools in Austria to that in Azerbaijan?
Your answer should be compact. 0.9. What is the difference between the highest and the second highest Gross enrolment ratio (%) in Pre-primary schools?
Provide a succinct answer. 0.21. What is the difference between the highest and the second highest Gross enrolment ratio (%) of Primary schools?
Offer a terse response. 0.12. What is the difference between the highest and the second highest Gross enrolment ratio (%) of Secondary schools?
Ensure brevity in your answer.  17.2. What is the difference between the highest and the second highest Gross enrolment ratio (%) in Tertiary schools?
Make the answer very short. 7.7. What is the difference between the highest and the lowest Gross enrolment ratio (%) in Pre-primary schools?
Give a very brief answer. 55.29. What is the difference between the highest and the lowest Gross enrolment ratio (%) of Primary schools?
Offer a very short reply. 26.69. What is the difference between the highest and the lowest Gross enrolment ratio (%) in Secondary schools?
Give a very brief answer. 69.32. What is the difference between the highest and the lowest Gross enrolment ratio (%) of Tertiary schools?
Keep it short and to the point. 33.84. 